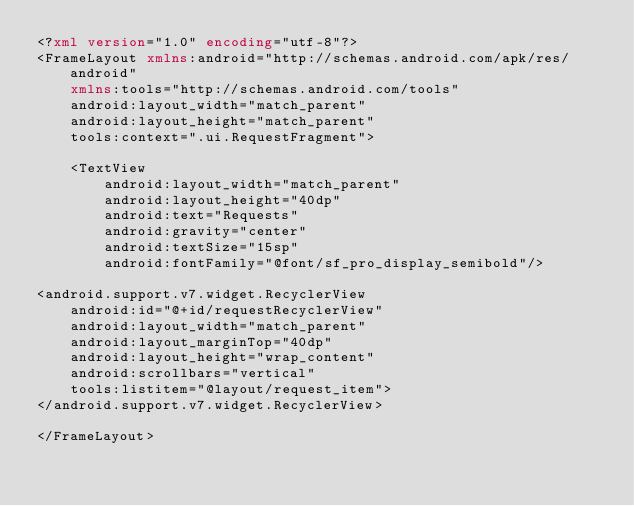<code> <loc_0><loc_0><loc_500><loc_500><_XML_><?xml version="1.0" encoding="utf-8"?>
<FrameLayout xmlns:android="http://schemas.android.com/apk/res/android"
    xmlns:tools="http://schemas.android.com/tools"
    android:layout_width="match_parent"
    android:layout_height="match_parent"
    tools:context=".ui.RequestFragment">

    <TextView
        android:layout_width="match_parent"
        android:layout_height="40dp"
        android:text="Requests"
        android:gravity="center"
        android:textSize="15sp"
        android:fontFamily="@font/sf_pro_display_semibold"/>

<android.support.v7.widget.RecyclerView
    android:id="@+id/requestRecyclerView"
    android:layout_width="match_parent"
    android:layout_marginTop="40dp"
    android:layout_height="wrap_content"
    android:scrollbars="vertical"
    tools:listitem="@layout/request_item">
</android.support.v7.widget.RecyclerView>

</FrameLayout></code> 